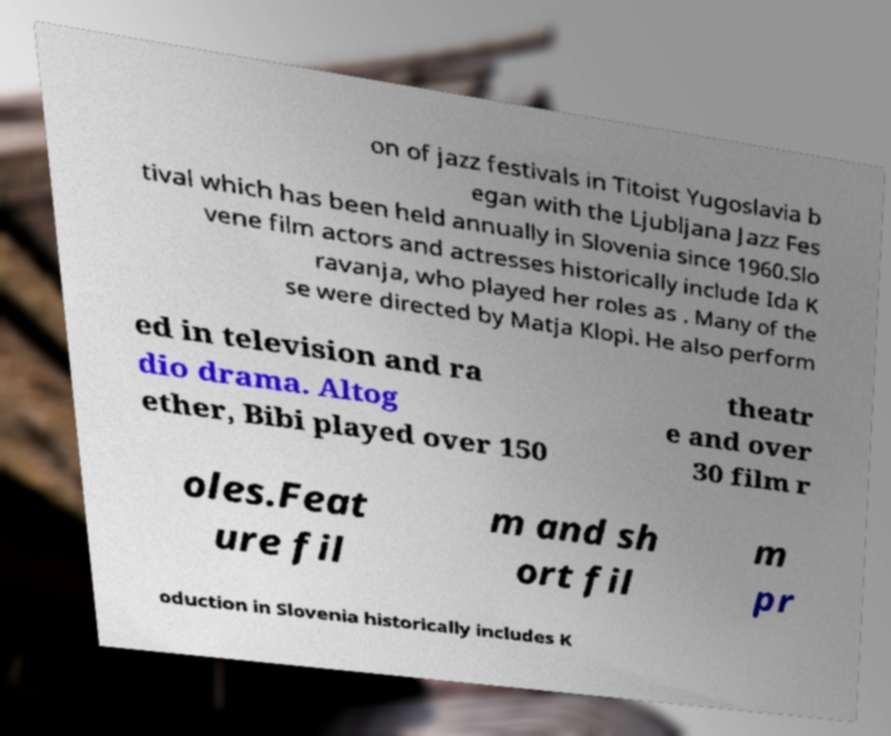I need the written content from this picture converted into text. Can you do that? on of jazz festivals in Titoist Yugoslavia b egan with the Ljubljana Jazz Fes tival which has been held annually in Slovenia since 1960.Slo vene film actors and actresses historically include Ida K ravanja, who played her roles as . Many of the se were directed by Matja Klopi. He also perform ed in television and ra dio drama. Altog ether, Bibi played over 150 theatr e and over 30 film r oles.Feat ure fil m and sh ort fil m pr oduction in Slovenia historically includes K 